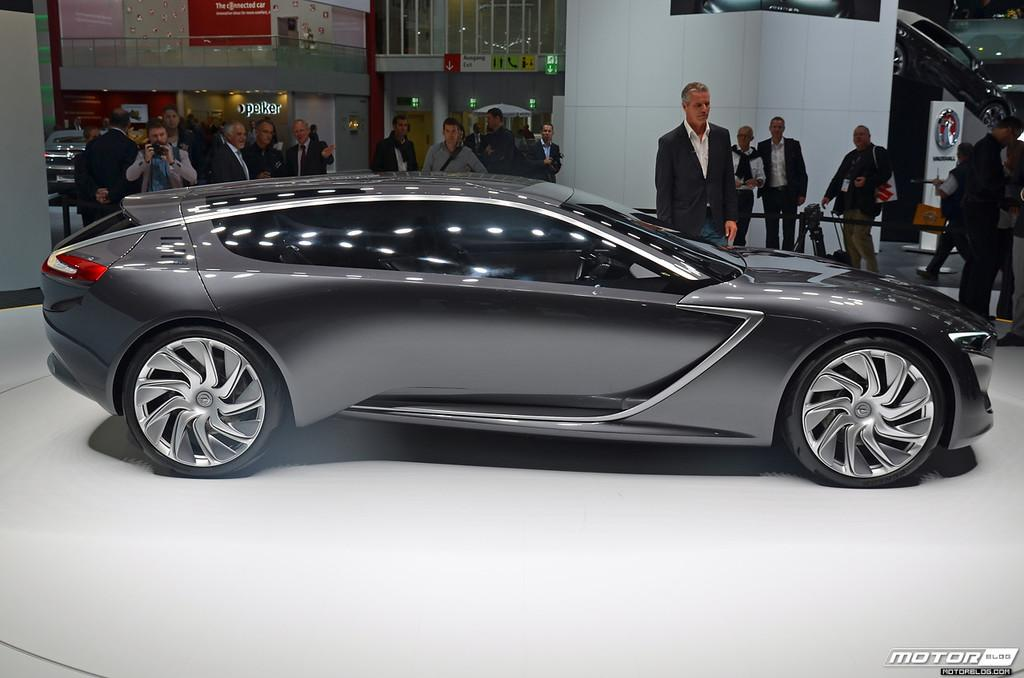What object is placed on the floor in the image? There is a car on the floor in the image. What can be seen in the background of the image? There is a crowd, a fence, and a wall in the background of the image. Where was the image taken? The image was taken in a shop. How many chairs can be seen in the image? There are no chairs present in the image. What type of flame is visible in the image? There is no flame present in the image. 